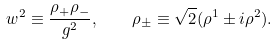Convert formula to latex. <formula><loc_0><loc_0><loc_500><loc_500>w ^ { 2 } \equiv \frac { \rho _ { + } \rho _ { - } } { g ^ { 2 } } , \quad \rho _ { \pm } \equiv \sqrt { 2 } ( \rho ^ { 1 } \pm i \rho ^ { 2 } ) .</formula> 